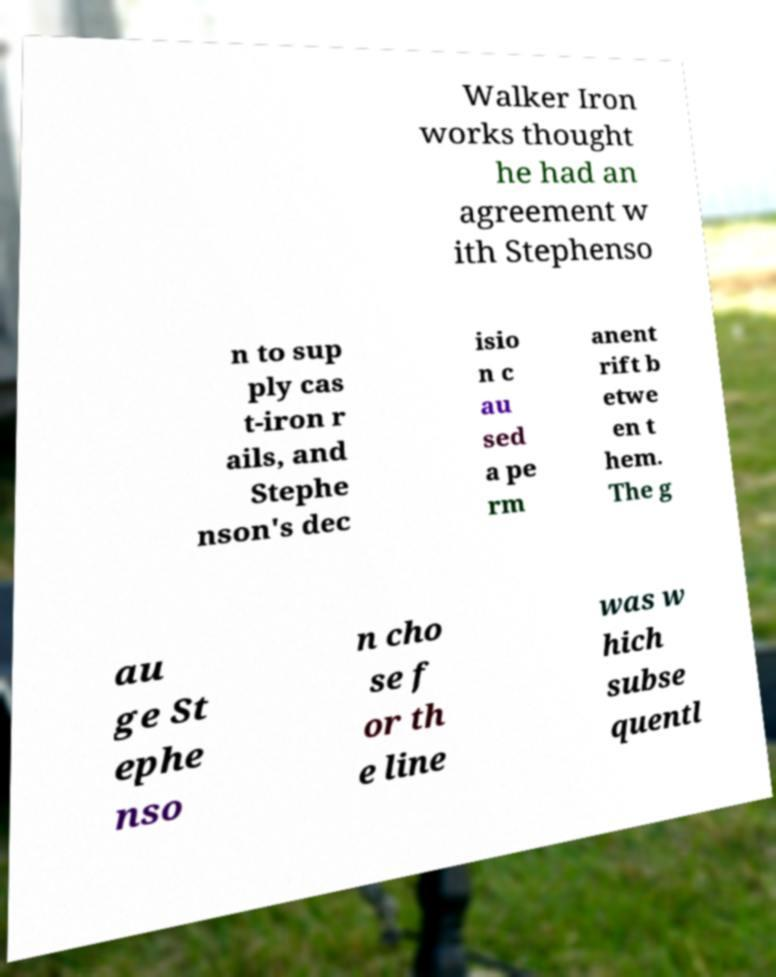What messages or text are displayed in this image? I need them in a readable, typed format. Walker Iron works thought he had an agreement w ith Stephenso n to sup ply cas t-iron r ails, and Stephe nson's dec isio n c au sed a pe rm anent rift b etwe en t hem. The g au ge St ephe nso n cho se f or th e line was w hich subse quentl 